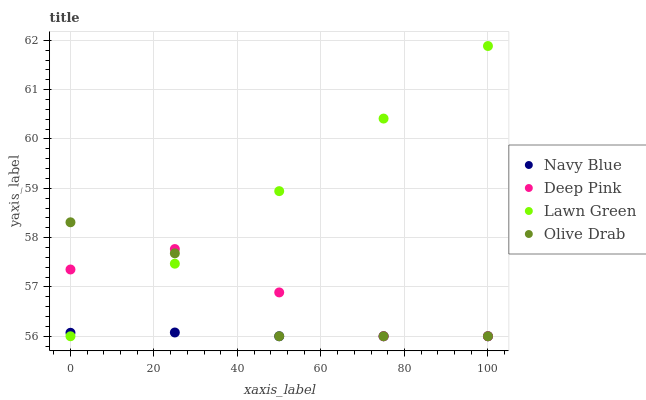Does Navy Blue have the minimum area under the curve?
Answer yes or no. Yes. Does Lawn Green have the maximum area under the curve?
Answer yes or no. Yes. Does Deep Pink have the minimum area under the curve?
Answer yes or no. No. Does Deep Pink have the maximum area under the curve?
Answer yes or no. No. Is Lawn Green the smoothest?
Answer yes or no. Yes. Is Olive Drab the roughest?
Answer yes or no. Yes. Is Deep Pink the smoothest?
Answer yes or no. No. Is Deep Pink the roughest?
Answer yes or no. No. Does Navy Blue have the lowest value?
Answer yes or no. Yes. Does Lawn Green have the highest value?
Answer yes or no. Yes. Does Deep Pink have the highest value?
Answer yes or no. No. Does Olive Drab intersect Deep Pink?
Answer yes or no. Yes. Is Olive Drab less than Deep Pink?
Answer yes or no. No. Is Olive Drab greater than Deep Pink?
Answer yes or no. No. 